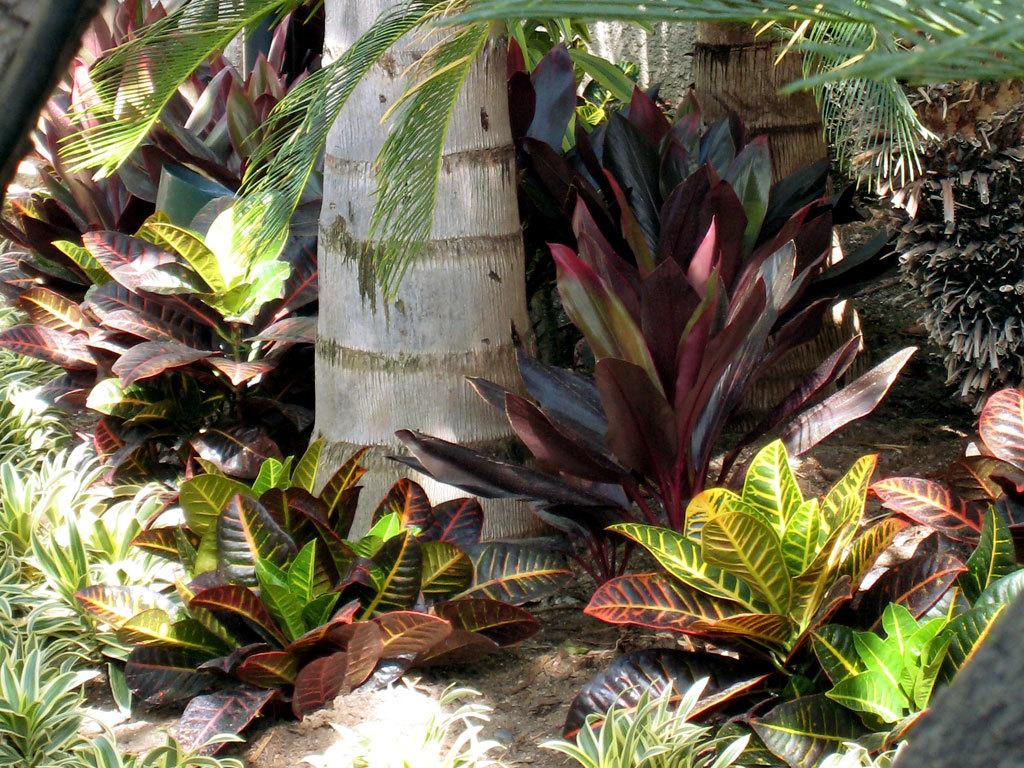What type of vegetation can be seen in the image? There is a tree and plants at the bottom of the image. Can you describe the tree in the image? The facts provided do not give specific details about the tree, but it is present in the image. What is the location of the plants in the image? The plants are at the bottom of the image. Where is the store located in the image? There is no store present in the image. What type of lizards can be seen in the image? There are no lizards present in the image. 